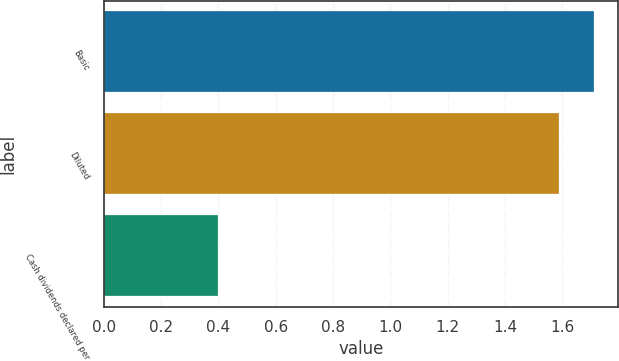<chart> <loc_0><loc_0><loc_500><loc_500><bar_chart><fcel>Basic<fcel>Diluted<fcel>Cash dividends declared per<nl><fcel>1.71<fcel>1.59<fcel>0.4<nl></chart> 